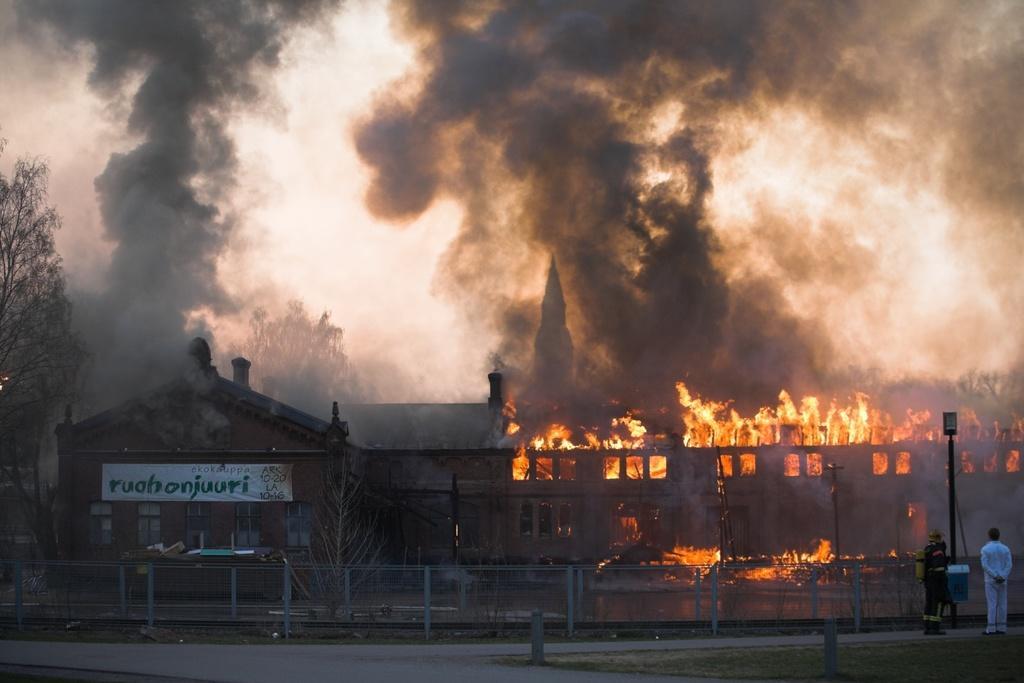Can you describe this image briefly? At the bottom of this image, there is a road. On the right side, there are two poles and grass on the ground and there are two persons on a road. In the background, there is fire and smoke from a building, there are trees and sky. 